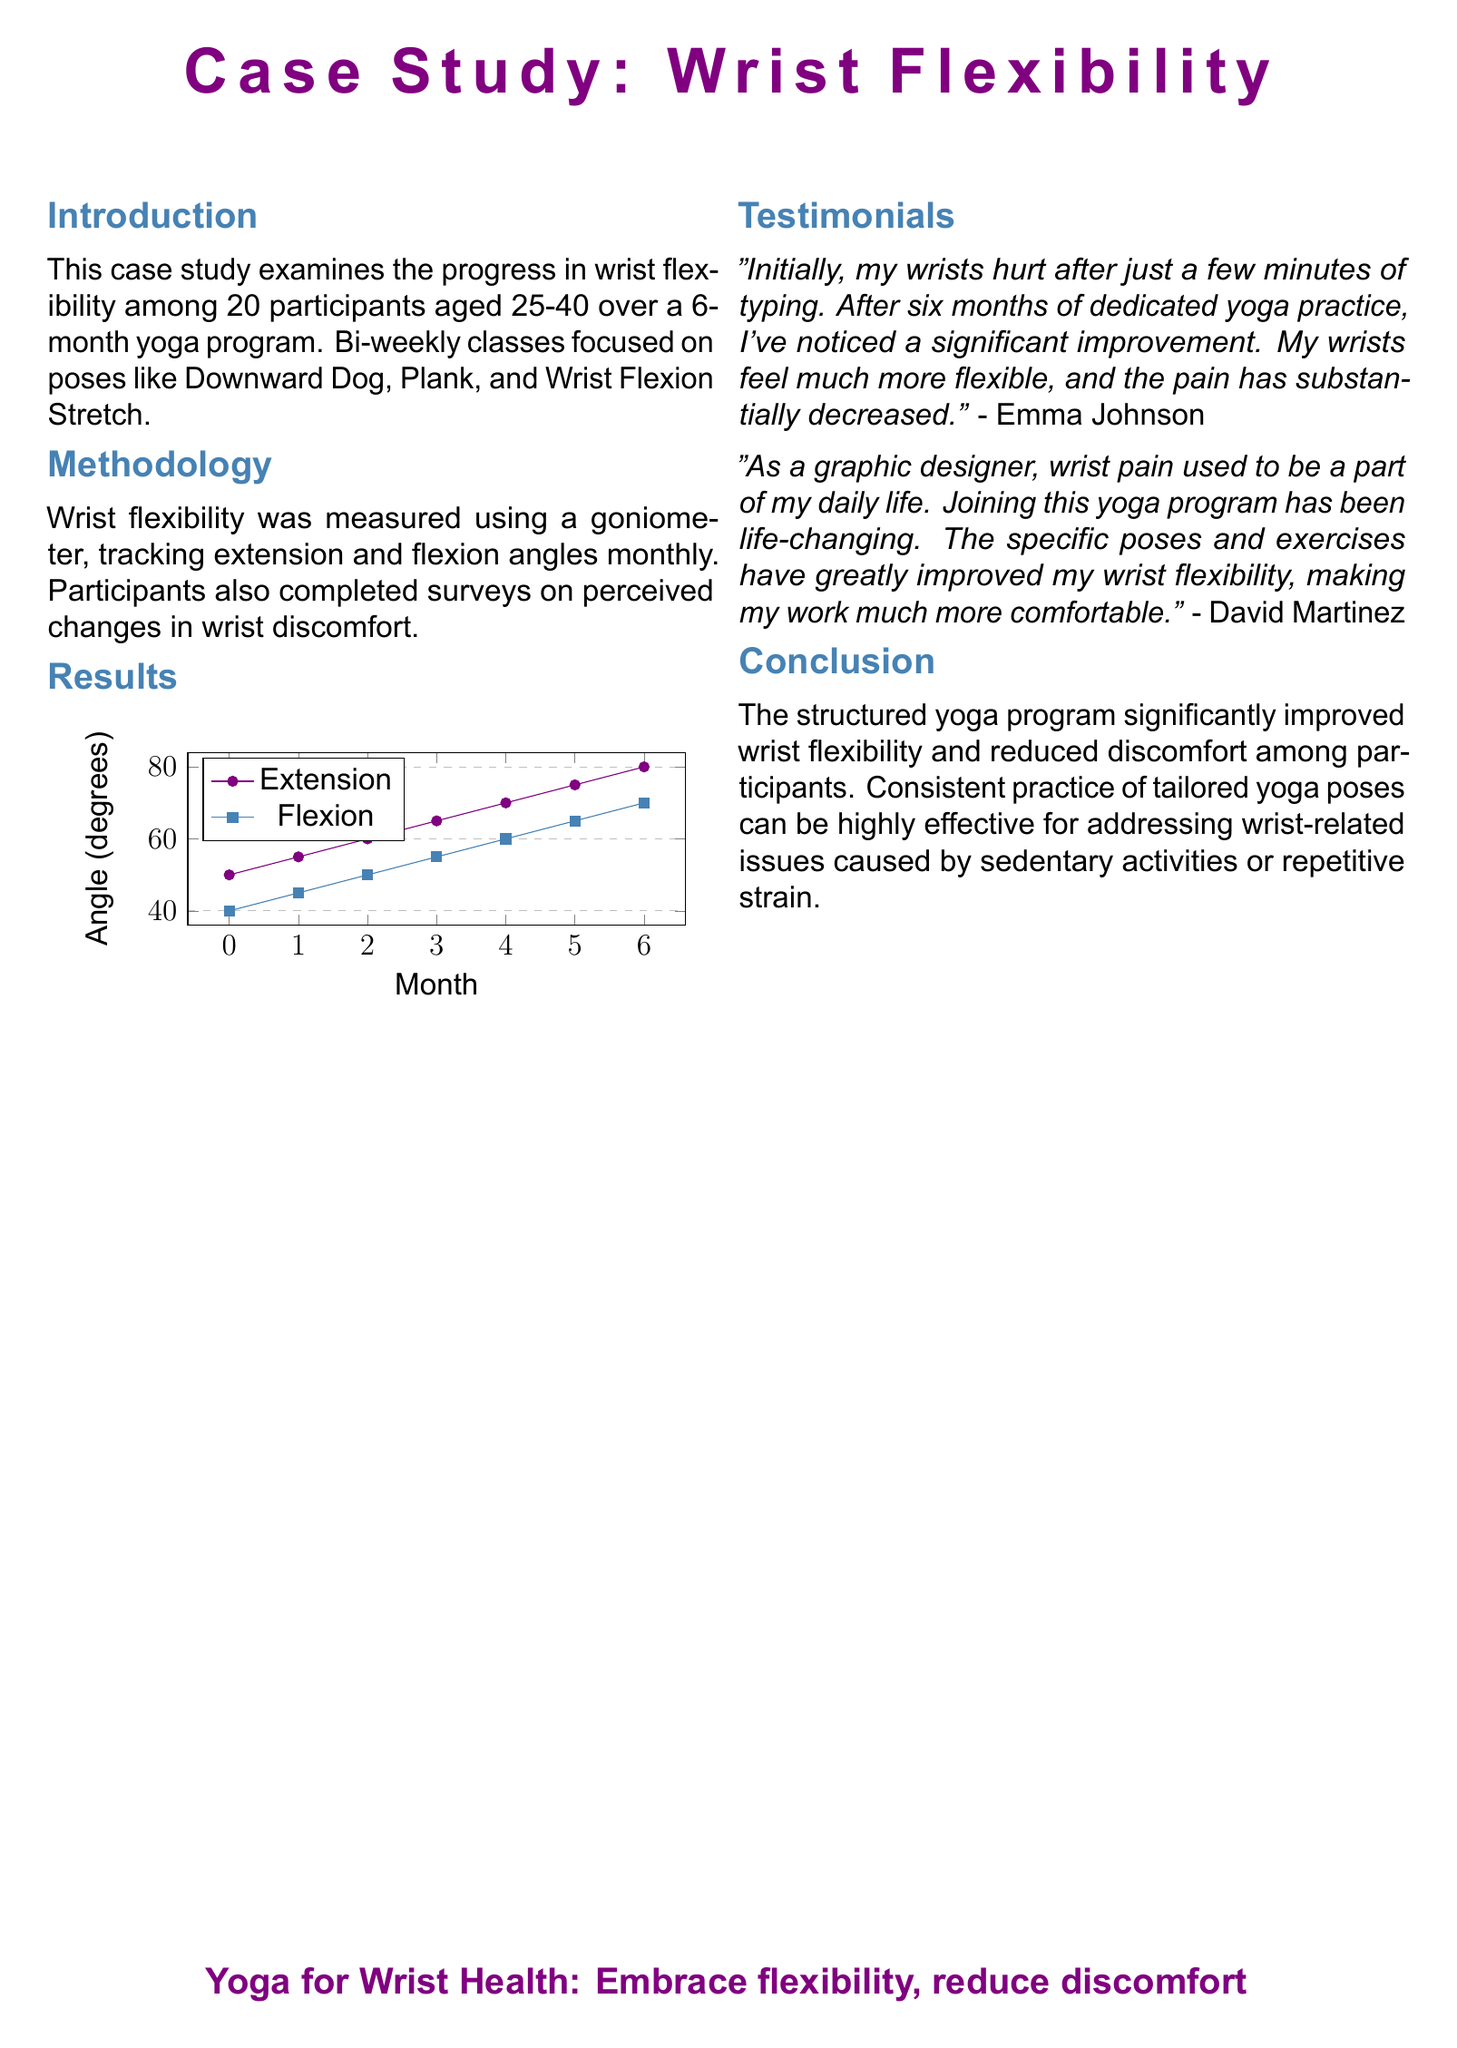What is the age range of participants? The age range of participants is given as 25-40 years in the introduction.
Answer: 25-40 How many participants were in the study? The introduction states that there were 20 participants in the case study.
Answer: 20 What poses were focused on during the yoga program? The introduction lists specific poses, including Downward Dog, Plank, and Wrist Flexion Stretch.
Answer: Downward Dog, Plank, Wrist Flexion Stretch What was the initial wrist extension angle? The chart indicates that the initial wrist extension angle was 50 degrees.
Answer: 50 degrees What was the final wrist flexion angle? At the end of the 6-month program, the final wrist flexion angle recorded was 70 degrees.
Answer: 70 degrees Who provided a testimonial about significant improvement? The testimonials section includes a person named Emma Johnson who noted a significant improvement.
Answer: Emma Johnson What notable change did David Martinez experience? David Martinez reported that joining the yoga program was life-changing and improved his wrist flexibility.
Answer: Life-changing What method was used to measure wrist flexibility? The methodology section states that a goniometer was used to measure wrist flexibility.
Answer: Goniometer What overall conclusion is drawn from the study? The conclusion mentions that the structured yoga program significantly improved wrist flexibility and reduced discomfort.
Answer: Improved wrist flexibility and reduced discomfort 